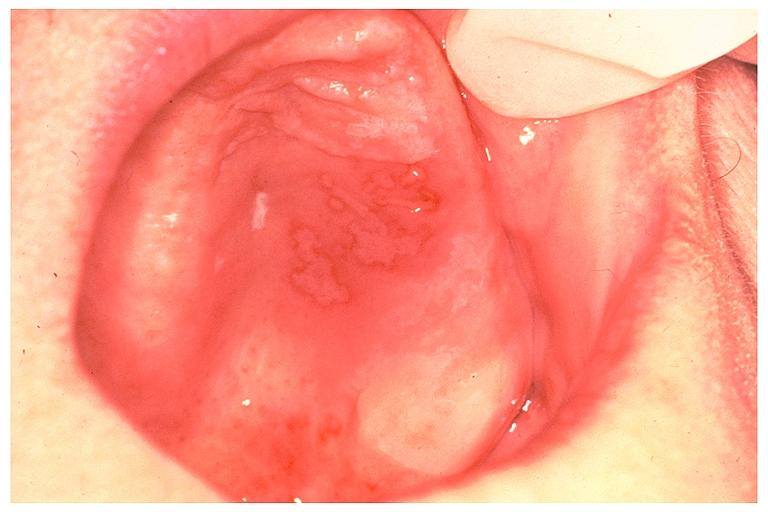s oral present?
Answer the question using a single word or phrase. Yes 